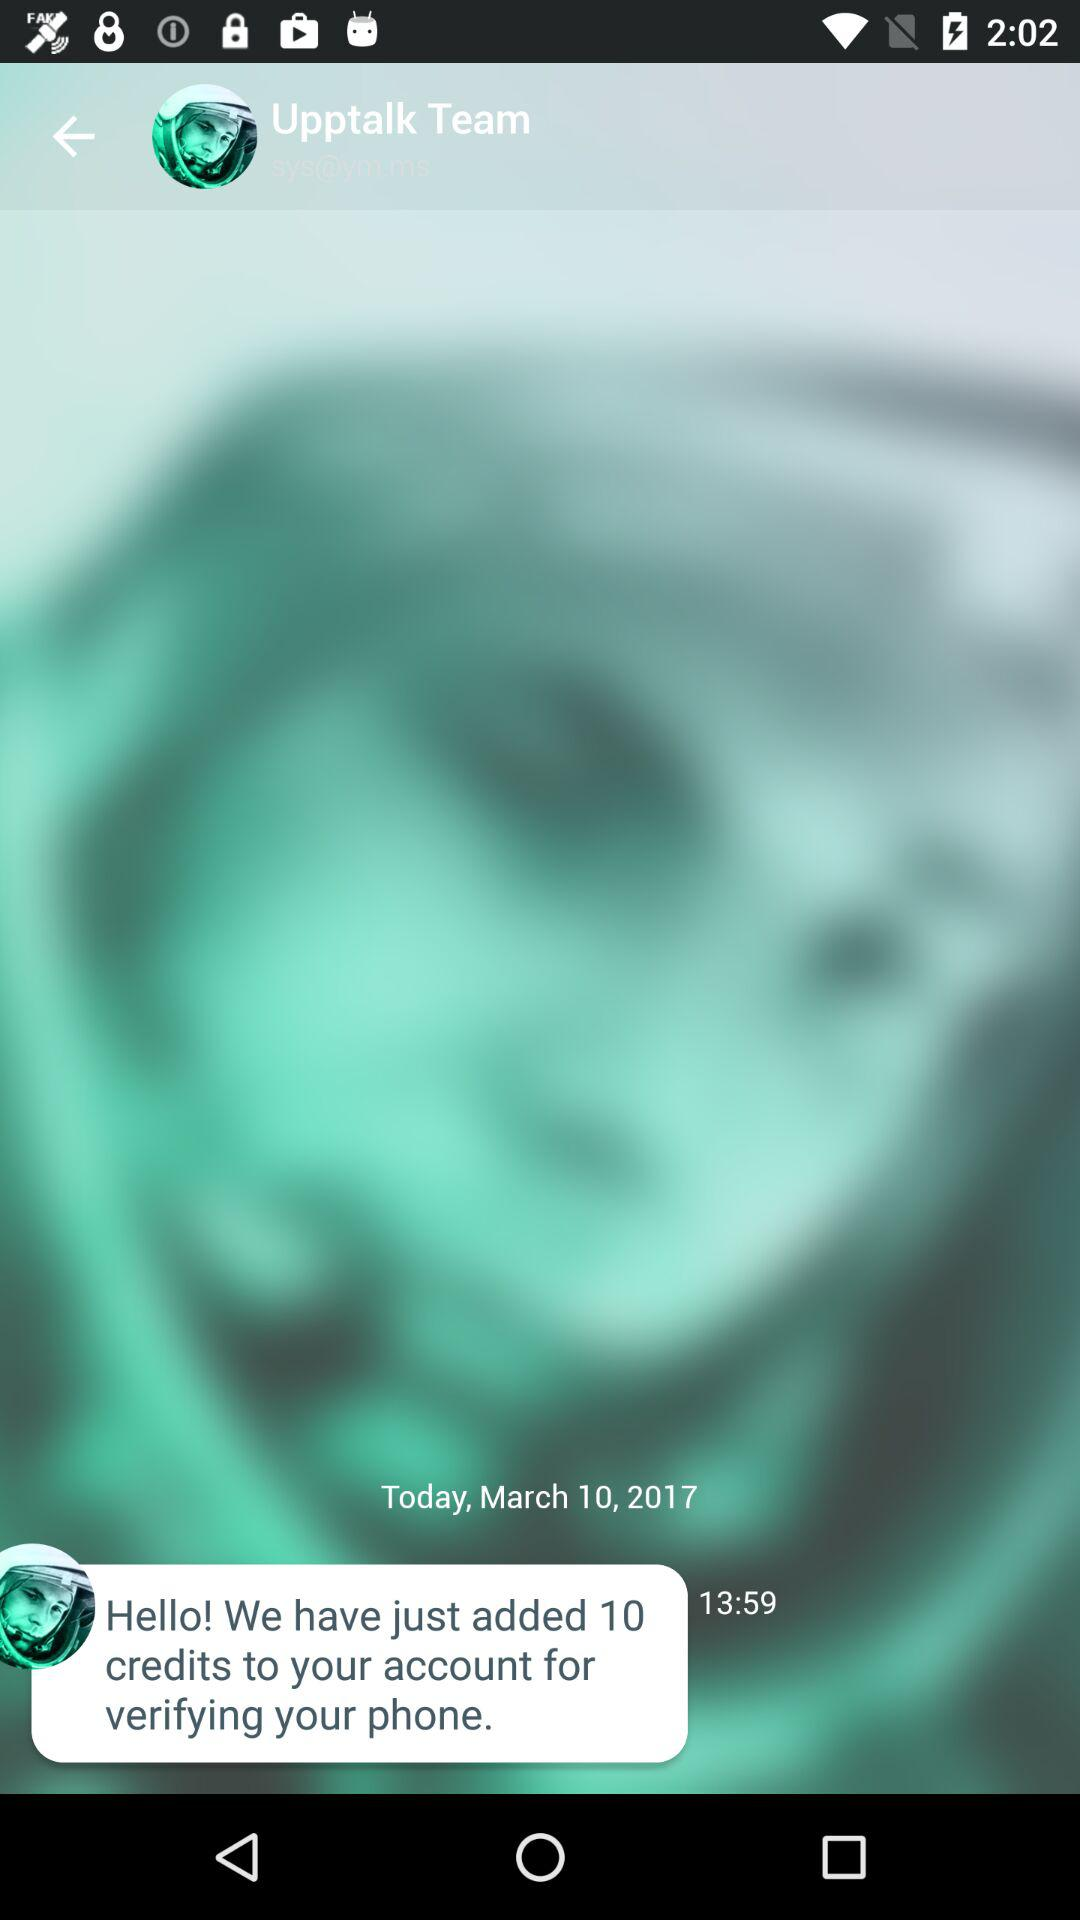What is the time of the last message? The time of the last message is 13:59. 